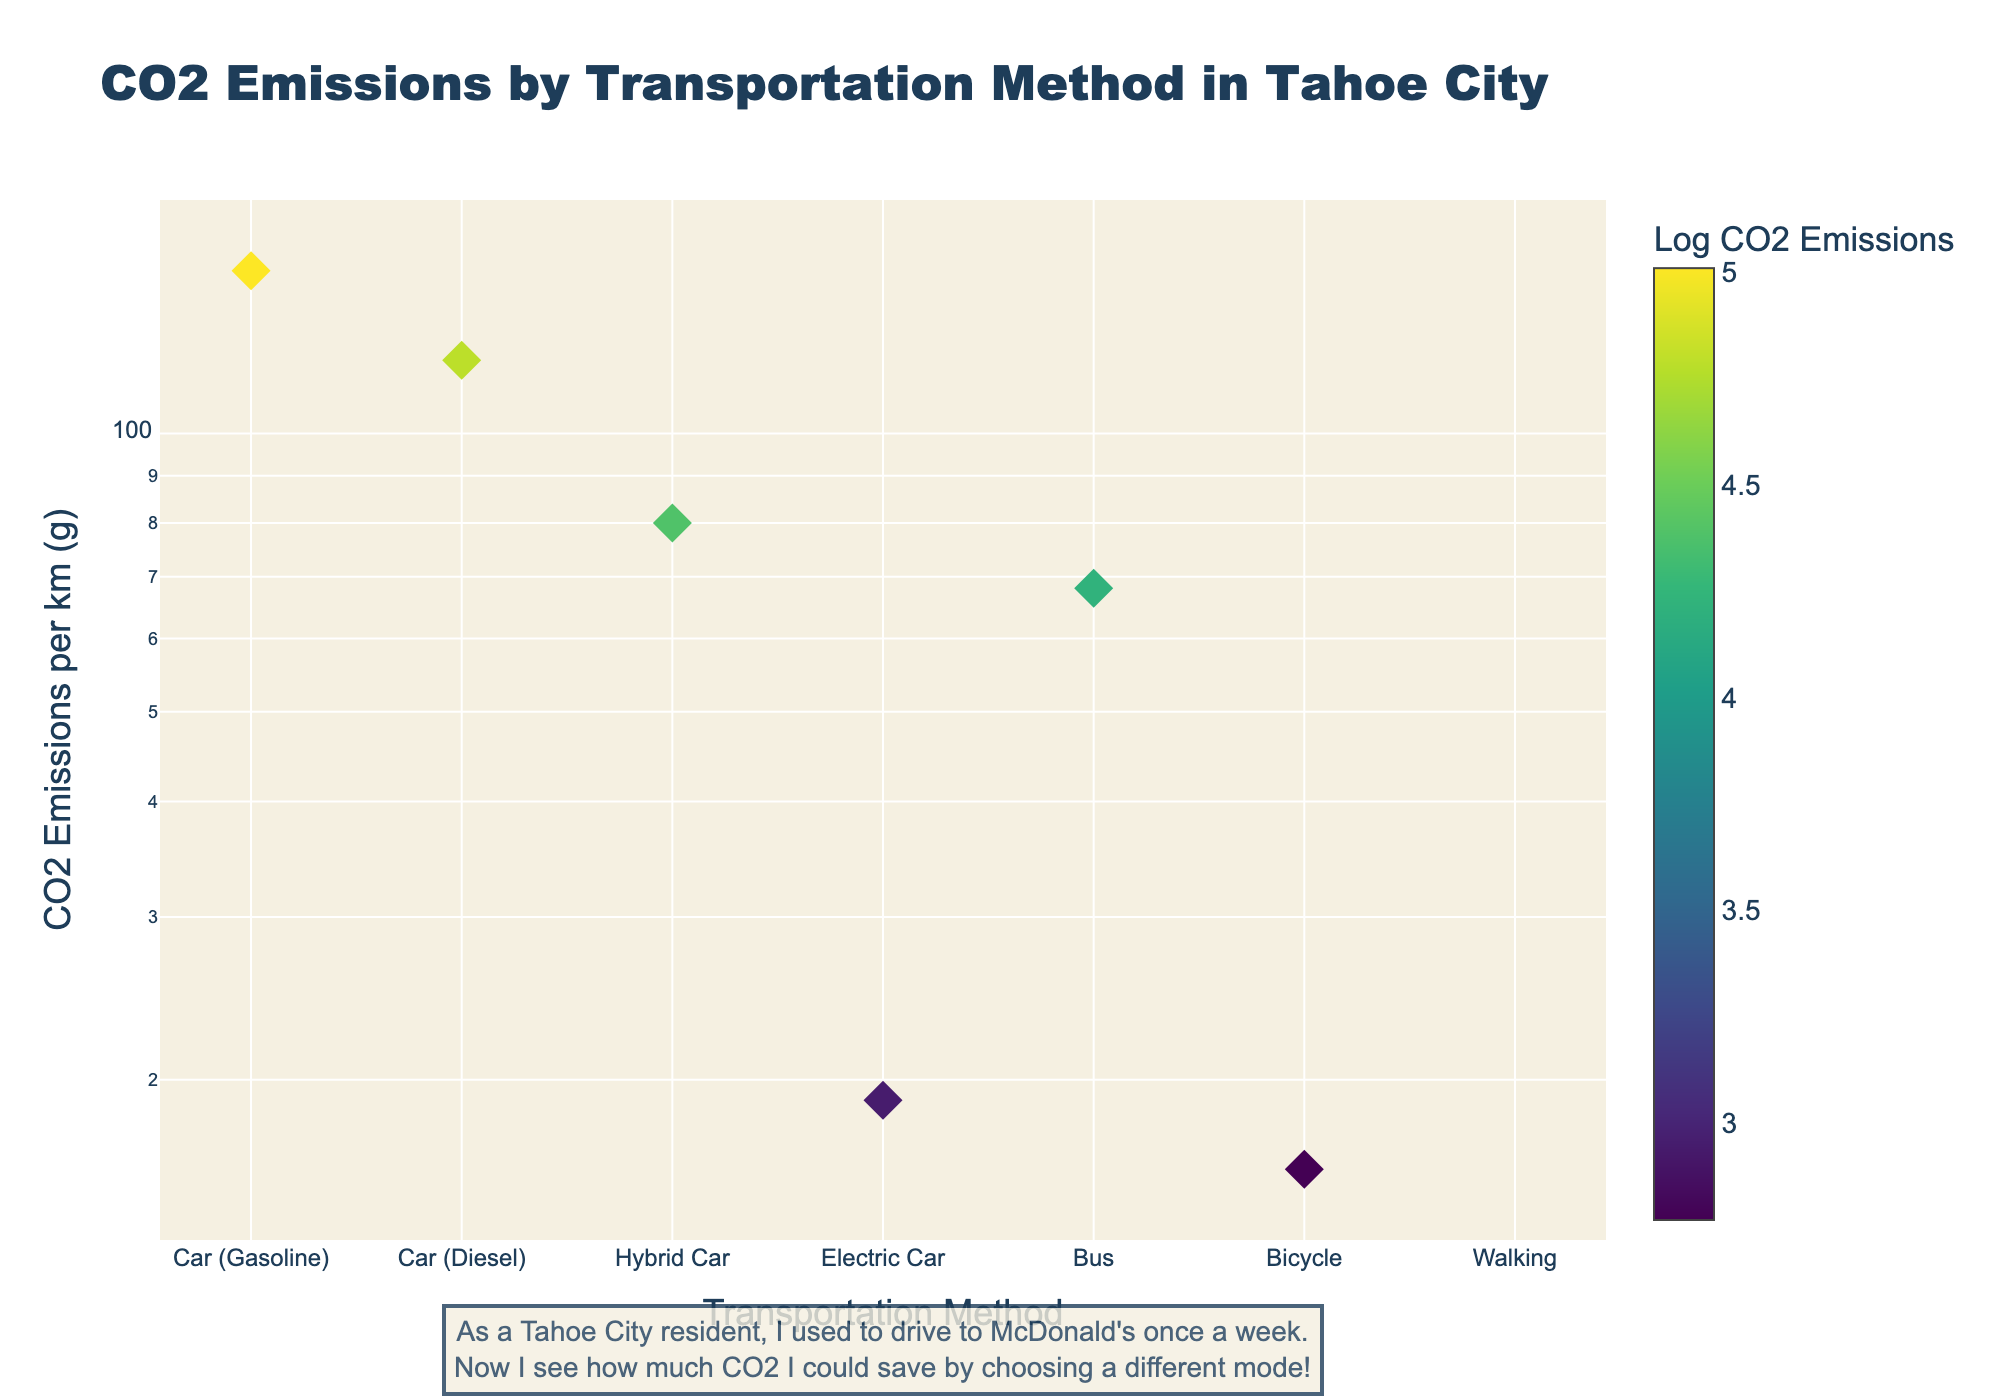what is the CO2 emissions of a hybrid car? We need to locate the data point for "Hybrid Car" on the x-axis and read the corresponding value on the y-axis. The emissions are 80 grams.
Answer: 80 grams Which transportation method has the lowest CO2 emissions per km among motor vehicles? Look for the motor vehicle with the smallest y-axis value. "Electric Car" has the lowest emissions, at 19 grams per km.
Answer: Electric Car What is the CO2 emission difference between a diesel car and a bus? Find the emissions for both "Car (Diesel)" and "Bus" on the y-axis. Subtract the bus emissions (68 grams) from the diesel car emissions (120 grams).
Answer: 52 grams How many transportation methods emit more than 100 grams of CO2 per km? Identify the data points above 100 grams on the y-axis. "Car (Gasoline)" and "Car (Diesel)" are the two methods.
Answer: 2 What is the range of CO2 emissions values displayed on the y-axis? Find the lowest and highest y-axis values. The emissions range from 0 to 150 grams per km.
Answer: 0 to 150 grams Which mode of transportation emits more CO2, a bus or a hybrid car? Compare the y-axis values of "Bus" and "Hybrid Car". The bus emits 68 grams, while the hybrid car emits 80 grams.
Answer: Hybrid Car How much more CO2 does a gas-powered car emit compared to an electric car? Subtract the emissions of the electric car (19 grams) from the emissions of the gasoline car (150 grams).
Answer: 131 grams What is the average CO2 emissions per km for all transportation methods? Sum all CO2 values (150 + 120 + 80 + 19 + 68 + 16 + 0 = 453 grams) and divide by the number of methods (7).
Answer: 64.71 grams 